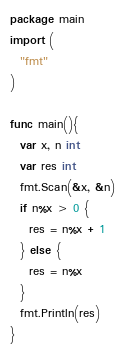Convert code to text. <code><loc_0><loc_0><loc_500><loc_500><_Go_>package main
import (
  "fmt"
)

func main(){
  var x, n int
  var res int
  fmt.Scan(&x, &n)
  if n%x > 0 {
    res = n%x + 1
  } else {
    res = n%x
  }
  fmt.Println(res)
}</code> 